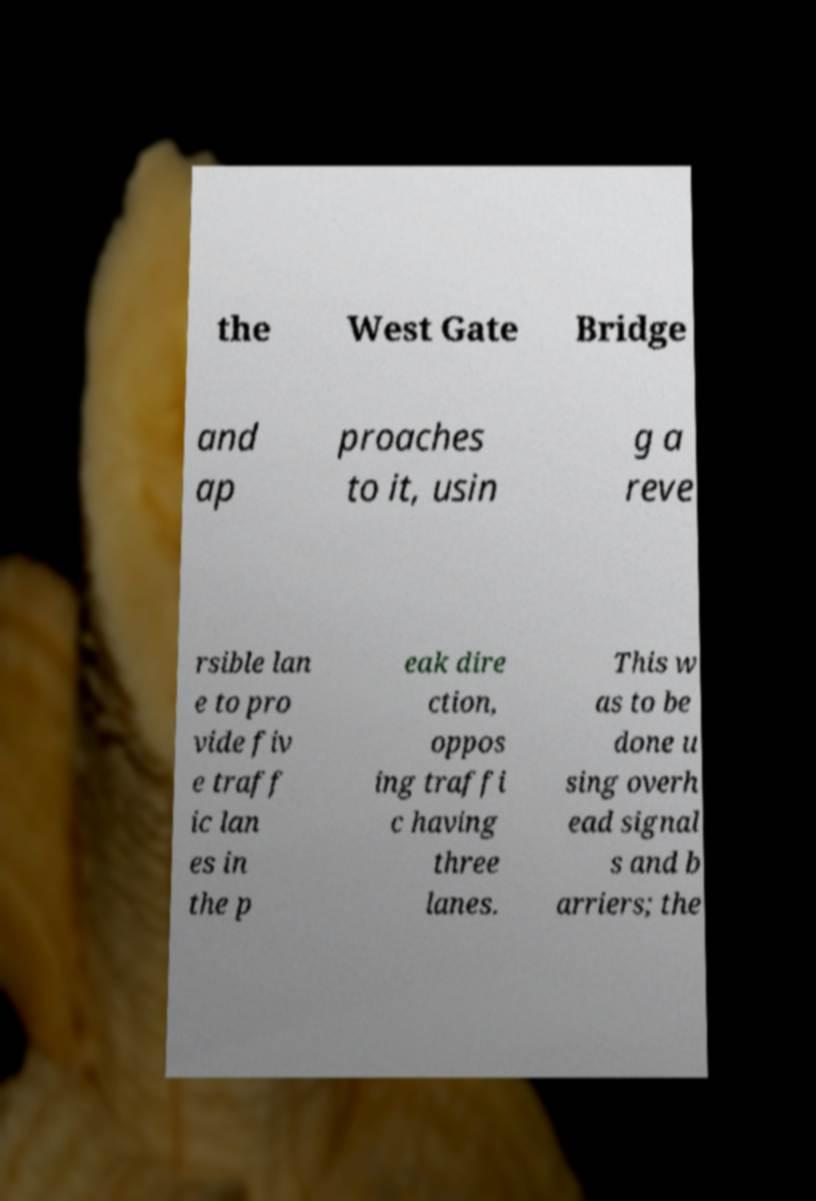Could you extract and type out the text from this image? the West Gate Bridge and ap proaches to it, usin g a reve rsible lan e to pro vide fiv e traff ic lan es in the p eak dire ction, oppos ing traffi c having three lanes. This w as to be done u sing overh ead signal s and b arriers; the 